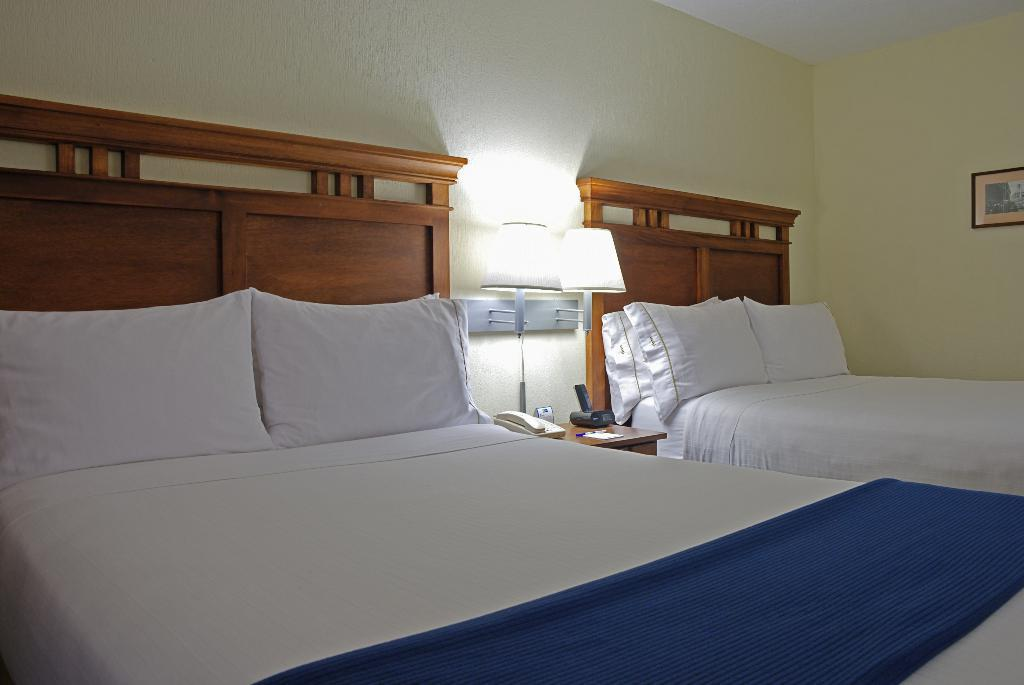How many beds are in the image? There are two beds in the image. What is on each bed? Each bed has two pillows on it. What piece of furniture is present in the image besides the beds? There is a table in the image. What is on the table? A lamp light is present on the table. What type of event is taking place in the image? There is no event taking place in the image; it is a still image of a room with two beds, pillows, a table, and a lamp light. 